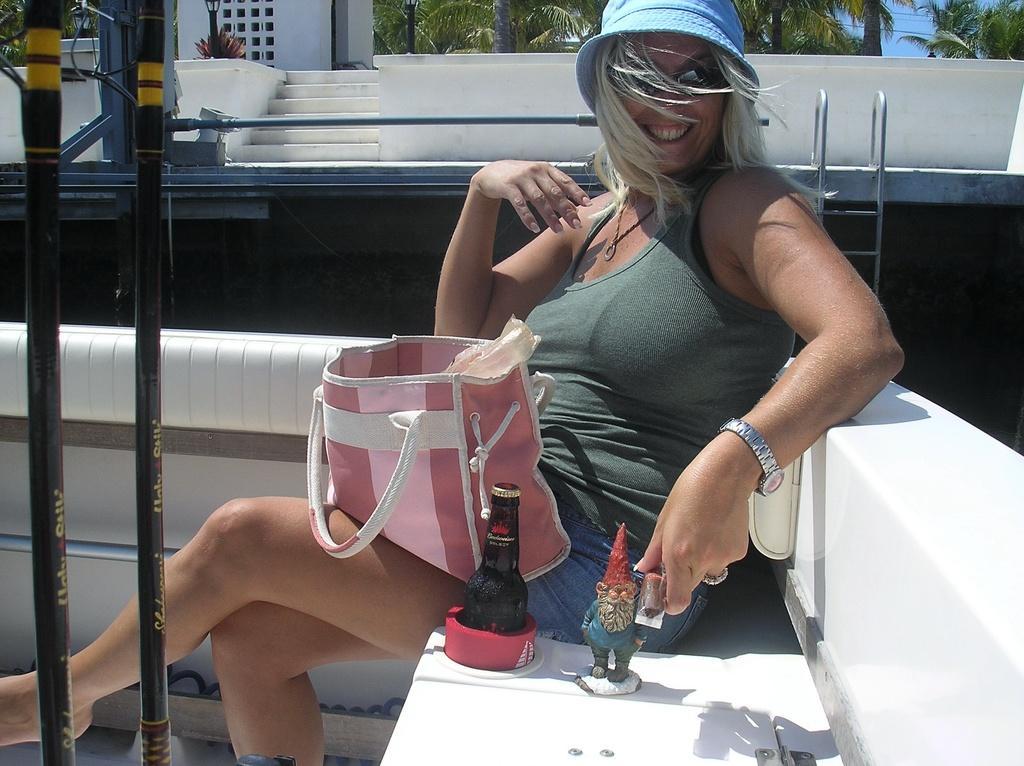In one or two sentences, can you explain what this image depicts? This picture is of outside. On the right there is a woman wearing green color t-shirt, smiling, holding an object and sitting on the bench. There is a toy and a glass bottle placed on the top of the bench and there is a purse placed on the lap of a woman. On the left corner there are metal rods. In the background we can see the sky, trees, plant, lamp, staircase and the building. 